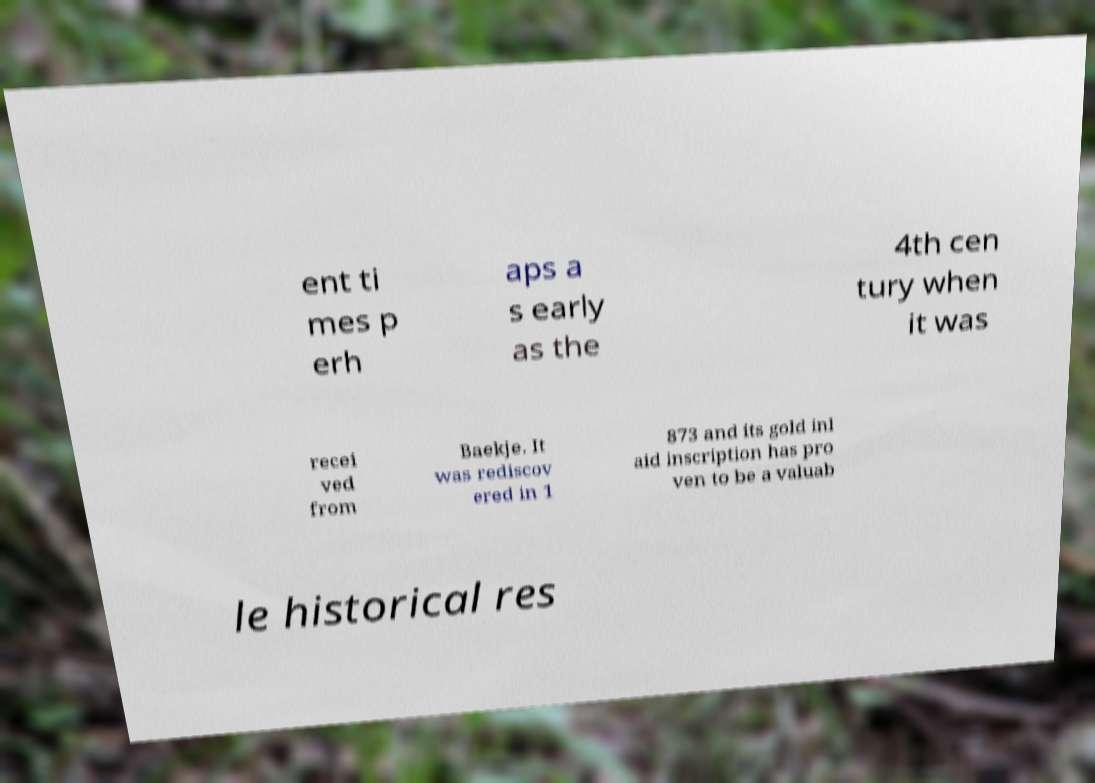Can you read and provide the text displayed in the image?This photo seems to have some interesting text. Can you extract and type it out for me? ent ti mes p erh aps a s early as the 4th cen tury when it was recei ved from Baekje. It was rediscov ered in 1 873 and its gold inl aid inscription has pro ven to be a valuab le historical res 